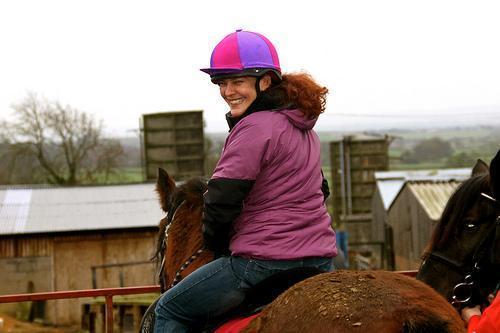How many horses are there?
Give a very brief answer. 2. 